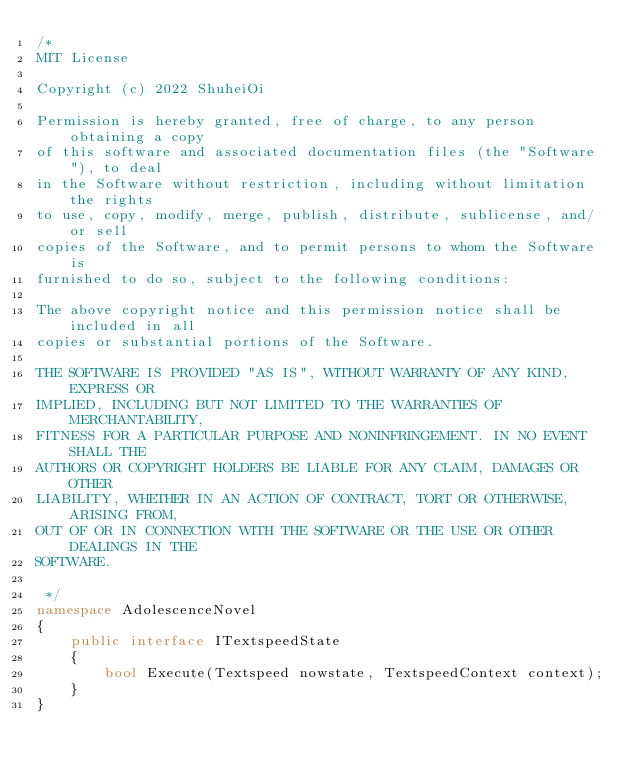Convert code to text. <code><loc_0><loc_0><loc_500><loc_500><_C#_>/*
MIT License

Copyright (c) 2022 ShuheiOi

Permission is hereby granted, free of charge, to any person obtaining a copy
of this software and associated documentation files (the "Software"), to deal
in the Software without restriction, including without limitation the rights
to use, copy, modify, merge, publish, distribute, sublicense, and/or sell
copies of the Software, and to permit persons to whom the Software is
furnished to do so, subject to the following conditions:

The above copyright notice and this permission notice shall be included in all
copies or substantial portions of the Software.

THE SOFTWARE IS PROVIDED "AS IS", WITHOUT WARRANTY OF ANY KIND, EXPRESS OR
IMPLIED, INCLUDING BUT NOT LIMITED TO THE WARRANTIES OF MERCHANTABILITY,
FITNESS FOR A PARTICULAR PURPOSE AND NONINFRINGEMENT. IN NO EVENT SHALL THE
AUTHORS OR COPYRIGHT HOLDERS BE LIABLE FOR ANY CLAIM, DAMAGES OR OTHER
LIABILITY, WHETHER IN AN ACTION OF CONTRACT, TORT OR OTHERWISE, ARISING FROM,
OUT OF OR IN CONNECTION WITH THE SOFTWARE OR THE USE OR OTHER DEALINGS IN THE
SOFTWARE.

 */
namespace AdolescenceNovel
{
    public interface ITextspeedState
    {
        bool Execute(Textspeed nowstate, TextspeedContext context);
    }
}
</code> 